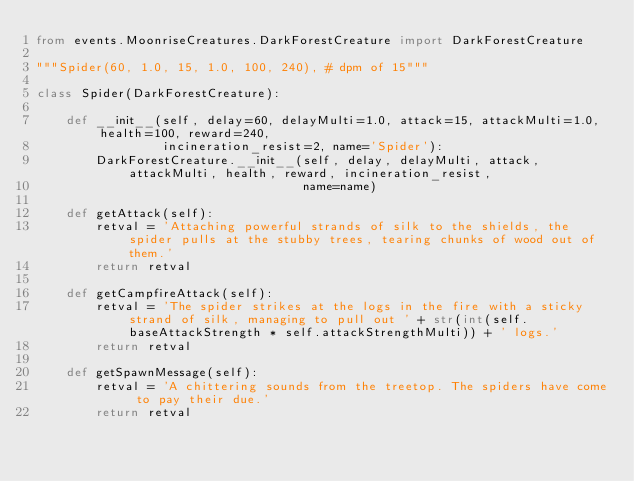Convert code to text. <code><loc_0><loc_0><loc_500><loc_500><_Python_>from events.MoonriseCreatures.DarkForestCreature import DarkForestCreature

"""Spider(60, 1.0, 15, 1.0, 100, 240), # dpm of 15"""

class Spider(DarkForestCreature):

    def __init__(self, delay=60, delayMulti=1.0, attack=15, attackMulti=1.0, health=100, reward=240,
                 incineration_resist=2, name='Spider'):
        DarkForestCreature.__init__(self, delay, delayMulti, attack, attackMulti, health, reward, incineration_resist,
                                    name=name)

    def getAttack(self):
        retval = 'Attaching powerful strands of silk to the shields, the spider pulls at the stubby trees, tearing chunks of wood out of them.'
        return retval

    def getCampfireAttack(self):
        retval = 'The spider strikes at the logs in the fire with a sticky strand of silk, managing to pull out ' + str(int(self.baseAttackStrength * self.attackStrengthMulti)) + ' logs.'
        return retval

    def getSpawnMessage(self):
        retval = 'A chittering sounds from the treetop. The spiders have come to pay their due.'
        return retval</code> 